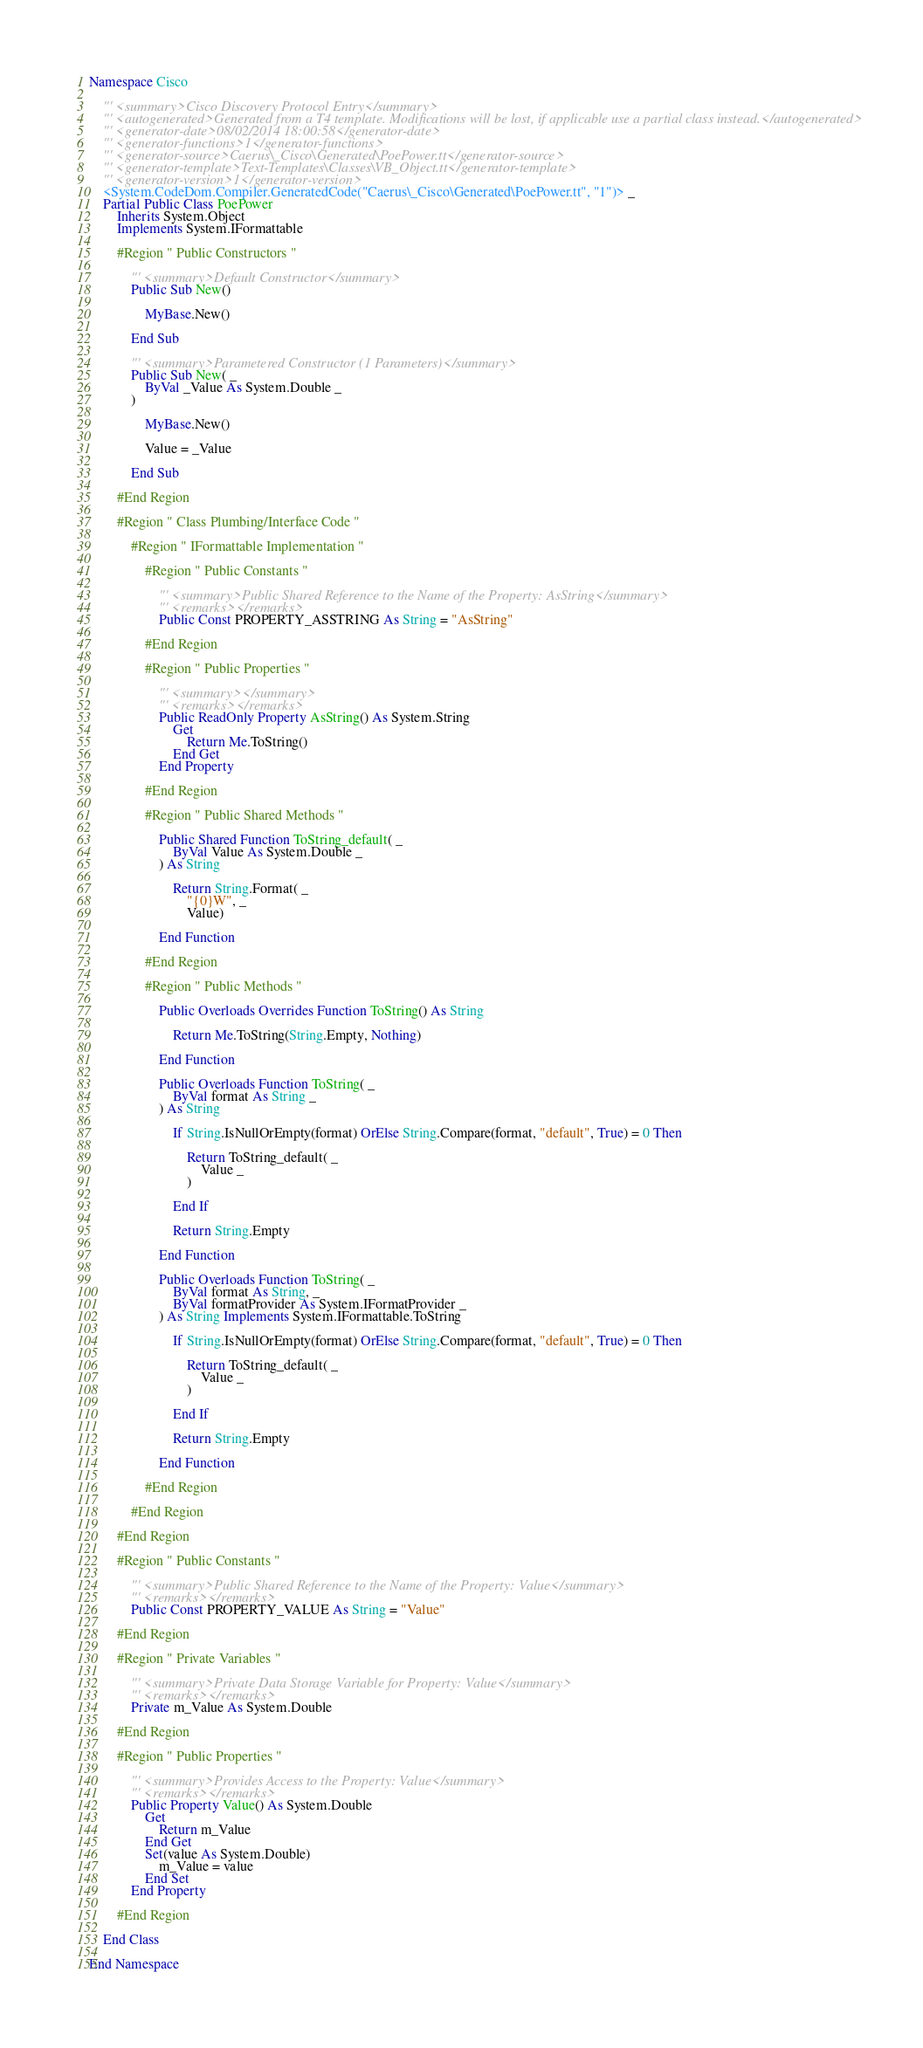<code> <loc_0><loc_0><loc_500><loc_500><_VisualBasic_>Namespace Cisco

	''' <summary>Cisco Discovery Protocol Entry</summary>
	''' <autogenerated>Generated from a T4 template. Modifications will be lost, if applicable use a partial class instead.</autogenerated>
	''' <generator-date>08/02/2014 18:00:58</generator-date>
	''' <generator-functions>1</generator-functions>
	''' <generator-source>Caerus\_Cisco\Generated\PoePower.tt</generator-source>
	''' <generator-template>Text-Templates\Classes\VB_Object.tt</generator-template>
	''' <generator-version>1</generator-version>
	<System.CodeDom.Compiler.GeneratedCode("Caerus\_Cisco\Generated\PoePower.tt", "1")> _
	Partial Public Class PoePower
		Inherits System.Object
		Implements System.IFormattable

		#Region " Public Constructors "

			''' <summary>Default Constructor</summary>
			Public Sub New()

				MyBase.New()

			End Sub

			''' <summary>Parametered Constructor (1 Parameters)</summary>
			Public Sub New( _
				ByVal _Value As System.Double _
			)

				MyBase.New()

				Value = _Value

			End Sub

		#End Region

		#Region " Class Plumbing/Interface Code "

			#Region " IFormattable Implementation "

				#Region " Public Constants "

					''' <summary>Public Shared Reference to the Name of the Property: AsString</summary>
					''' <remarks></remarks>
					Public Const PROPERTY_ASSTRING As String = "AsString"

				#End Region

				#Region " Public Properties "

					''' <summary></summary>
					''' <remarks></remarks>
					Public ReadOnly Property AsString() As System.String
						Get
							Return Me.ToString()
						End Get
					End Property

				#End Region

				#Region " Public Shared Methods "

					Public Shared Function ToString_default( _
						ByVal Value As System.Double _
					) As String

						Return String.Format( _
							"{0}W", _
							Value)

					End Function

				#End Region

				#Region " Public Methods "

					Public Overloads Overrides Function ToString() As String

						Return Me.ToString(String.Empty, Nothing)

					End Function

					Public Overloads Function ToString( _
						ByVal format As String _
					) As String

						If String.IsNullOrEmpty(format) OrElse String.Compare(format, "default", True) = 0 Then

							Return ToString_default( _
								Value _
							)

						End If

						Return String.Empty

					End Function

					Public Overloads Function ToString( _
						ByVal format As String, _
						ByVal formatProvider As System.IFormatProvider _
					) As String Implements System.IFormattable.ToString

						If String.IsNullOrEmpty(format) OrElse String.Compare(format, "default", True) = 0 Then	

							Return ToString_default( _
								Value _
							)

						End If

						Return String.Empty

					End Function

				#End Region

			#End Region

		#End Region

		#Region " Public Constants "

			''' <summary>Public Shared Reference to the Name of the Property: Value</summary>
			''' <remarks></remarks>
			Public Const PROPERTY_VALUE As String = "Value"

		#End Region

		#Region " Private Variables "

			''' <summary>Private Data Storage Variable for Property: Value</summary>
			''' <remarks></remarks>
			Private m_Value As System.Double

		#End Region

		#Region " Public Properties "

			''' <summary>Provides Access to the Property: Value</summary>
			''' <remarks></remarks>
			Public Property Value() As System.Double
				Get
					Return m_Value
				End Get
				Set(value As System.Double)
					m_Value = value
				End Set
			End Property

		#End Region

	End Class

End Namespace</code> 